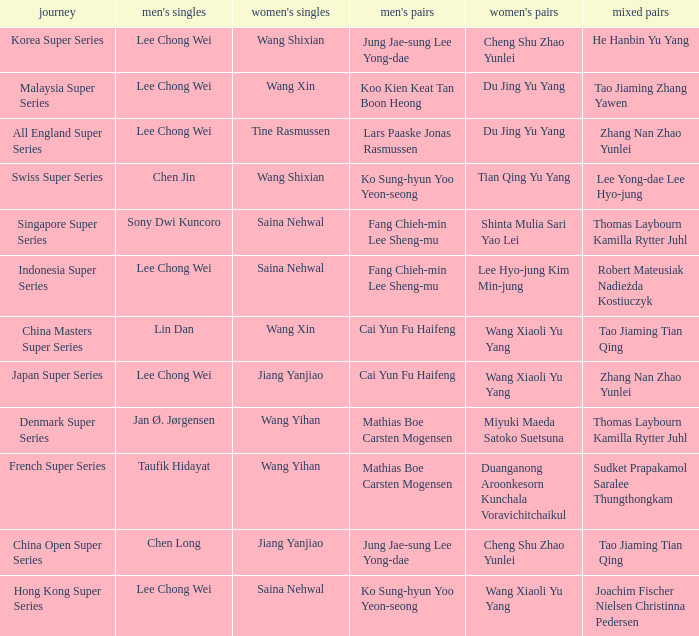Who is the womens doubles on the tour french super series? Duanganong Aroonkesorn Kunchala Voravichitchaikul. 